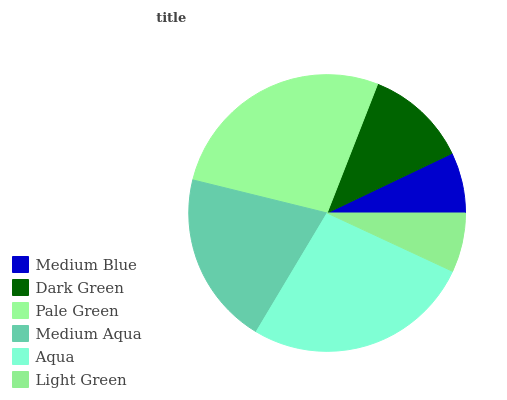Is Light Green the minimum?
Answer yes or no. Yes. Is Pale Green the maximum?
Answer yes or no. Yes. Is Dark Green the minimum?
Answer yes or no. No. Is Dark Green the maximum?
Answer yes or no. No. Is Dark Green greater than Medium Blue?
Answer yes or no. Yes. Is Medium Blue less than Dark Green?
Answer yes or no. Yes. Is Medium Blue greater than Dark Green?
Answer yes or no. No. Is Dark Green less than Medium Blue?
Answer yes or no. No. Is Medium Aqua the high median?
Answer yes or no. Yes. Is Dark Green the low median?
Answer yes or no. Yes. Is Aqua the high median?
Answer yes or no. No. Is Medium Aqua the low median?
Answer yes or no. No. 